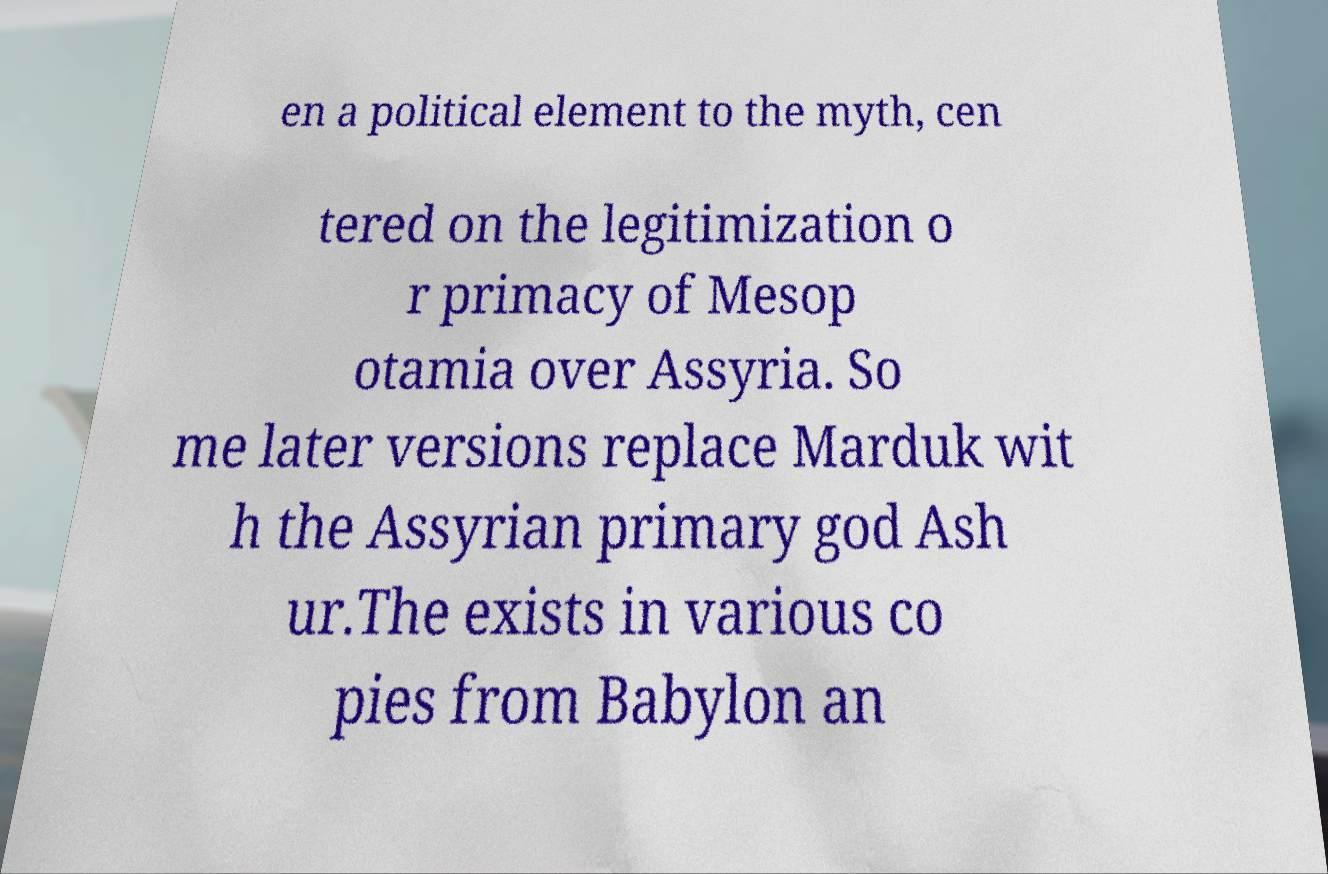Please read and relay the text visible in this image. What does it say? en a political element to the myth, cen tered on the legitimization o r primacy of Mesop otamia over Assyria. So me later versions replace Marduk wit h the Assyrian primary god Ash ur.The exists in various co pies from Babylon an 